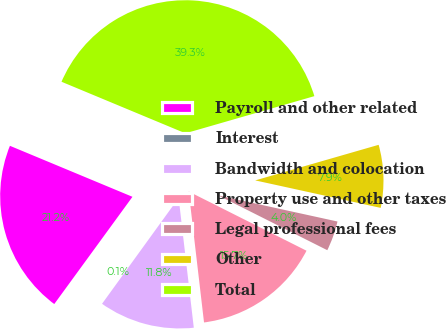Convert chart. <chart><loc_0><loc_0><loc_500><loc_500><pie_chart><fcel>Payroll and other related<fcel>Interest<fcel>Bandwidth and colocation<fcel>Property use and other taxes<fcel>Legal professional fees<fcel>Other<fcel>Total<nl><fcel>21.25%<fcel>0.06%<fcel>11.82%<fcel>15.74%<fcel>3.98%<fcel>7.9%<fcel>39.26%<nl></chart> 